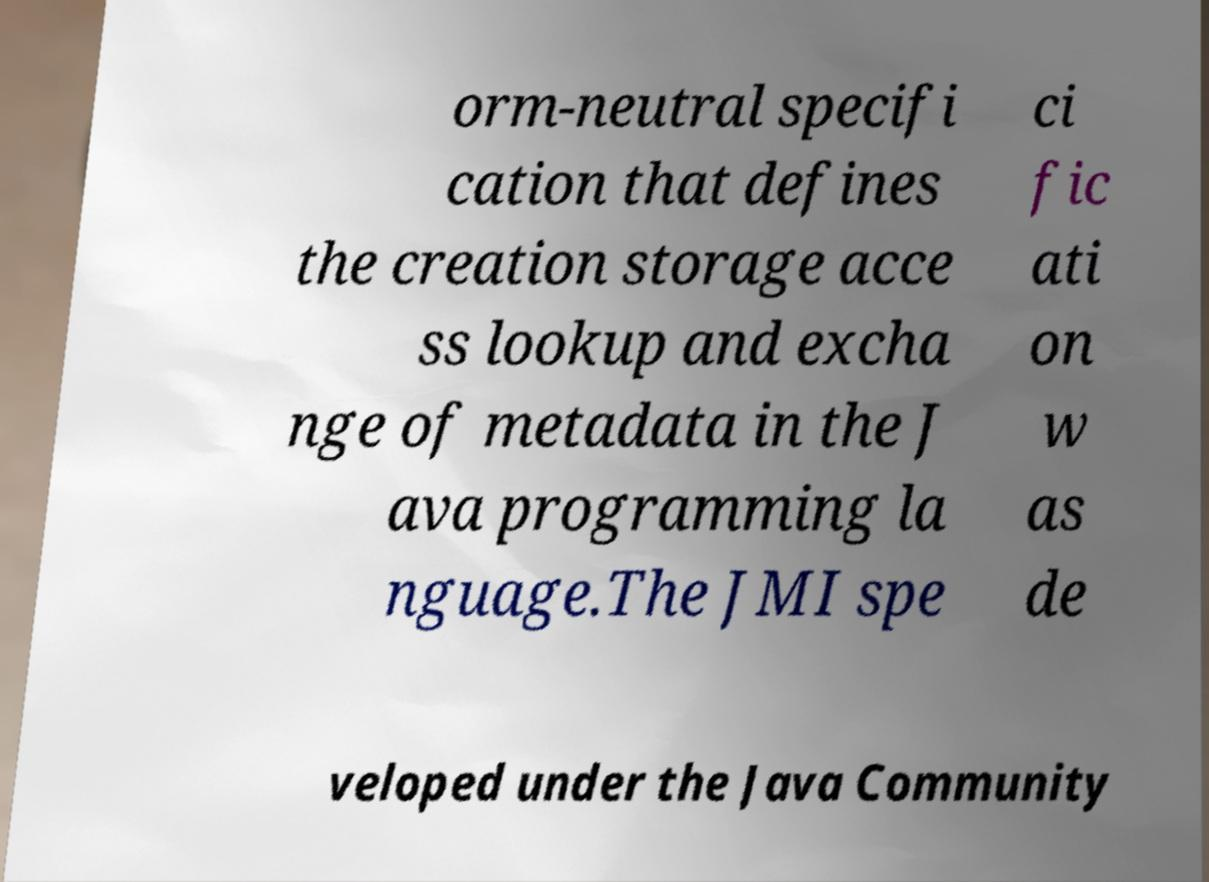Could you extract and type out the text from this image? orm-neutral specifi cation that defines the creation storage acce ss lookup and excha nge of metadata in the J ava programming la nguage.The JMI spe ci fic ati on w as de veloped under the Java Community 